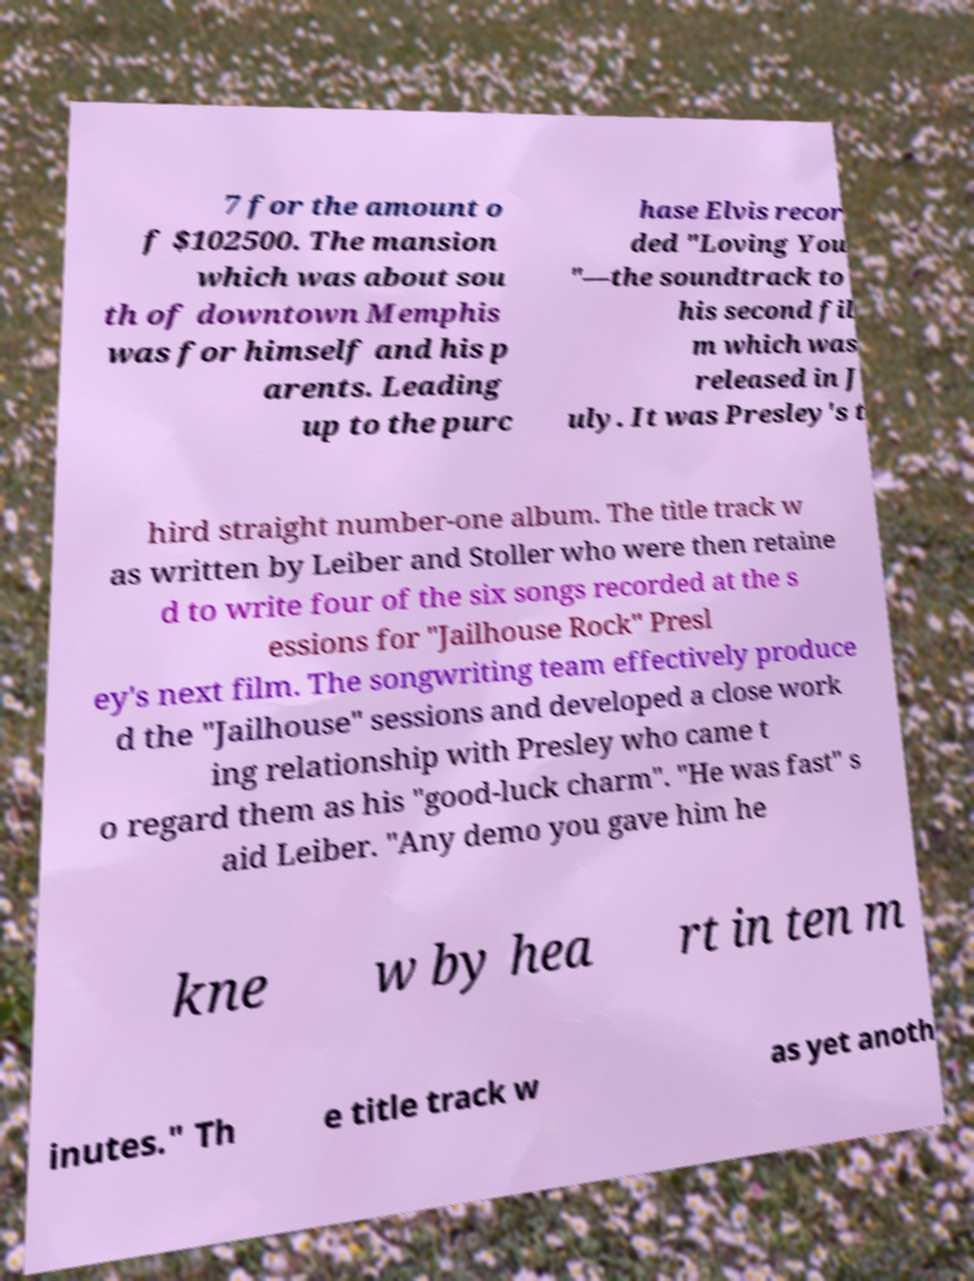I need the written content from this picture converted into text. Can you do that? 7 for the amount o f $102500. The mansion which was about sou th of downtown Memphis was for himself and his p arents. Leading up to the purc hase Elvis recor ded "Loving You "—the soundtrack to his second fil m which was released in J uly. It was Presley's t hird straight number-one album. The title track w as written by Leiber and Stoller who were then retaine d to write four of the six songs recorded at the s essions for "Jailhouse Rock" Presl ey's next film. The songwriting team effectively produce d the "Jailhouse" sessions and developed a close work ing relationship with Presley who came t o regard them as his "good-luck charm". "He was fast" s aid Leiber. "Any demo you gave him he kne w by hea rt in ten m inutes." Th e title track w as yet anoth 